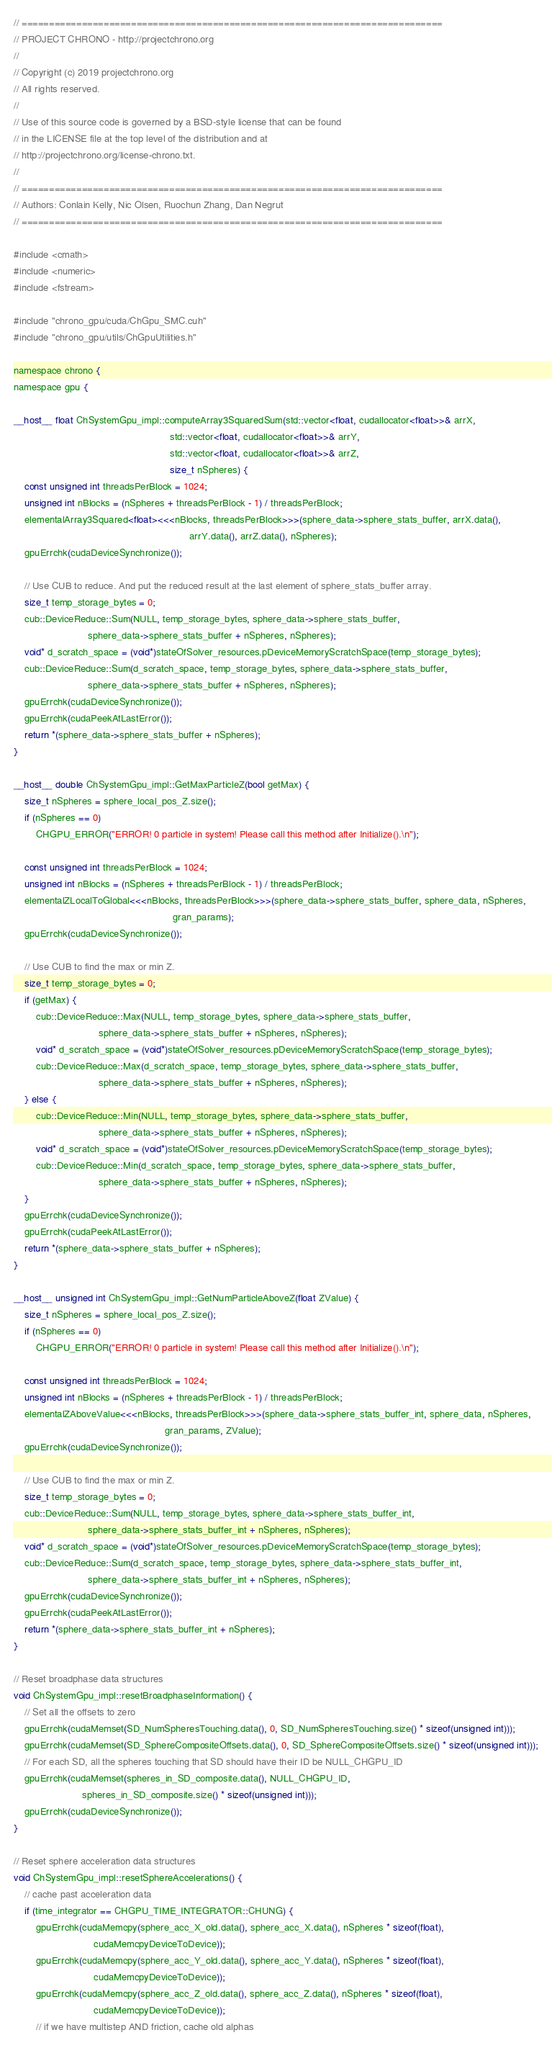Convert code to text. <code><loc_0><loc_0><loc_500><loc_500><_Cuda_>// =============================================================================
// PROJECT CHRONO - http://projectchrono.org
//
// Copyright (c) 2019 projectchrono.org
// All rights reserved.
//
// Use of this source code is governed by a BSD-style license that can be found
// in the LICENSE file at the top level of the distribution and at
// http://projectchrono.org/license-chrono.txt.
//
// =============================================================================
// Authors: Conlain Kelly, Nic Olsen, Ruochun Zhang, Dan Negrut
// =============================================================================

#include <cmath>
#include <numeric>
#include <fstream>

#include "chrono_gpu/cuda/ChGpu_SMC.cuh"
#include "chrono_gpu/utils/ChGpuUtilities.h"

namespace chrono {
namespace gpu {

__host__ float ChSystemGpu_impl::computeArray3SquaredSum(std::vector<float, cudallocator<float>>& arrX,
                                                         std::vector<float, cudallocator<float>>& arrY,
                                                         std::vector<float, cudallocator<float>>& arrZ,
                                                         size_t nSpheres) {
    const unsigned int threadsPerBlock = 1024;
    unsigned int nBlocks = (nSpheres + threadsPerBlock - 1) / threadsPerBlock;
    elementalArray3Squared<float><<<nBlocks, threadsPerBlock>>>(sphere_data->sphere_stats_buffer, arrX.data(),
                                                                arrY.data(), arrZ.data(), nSpheres);
    gpuErrchk(cudaDeviceSynchronize());

    // Use CUB to reduce. And put the reduced result at the last element of sphere_stats_buffer array.
    size_t temp_storage_bytes = 0;
    cub::DeviceReduce::Sum(NULL, temp_storage_bytes, sphere_data->sphere_stats_buffer,
                           sphere_data->sphere_stats_buffer + nSpheres, nSpheres);
    void* d_scratch_space = (void*)stateOfSolver_resources.pDeviceMemoryScratchSpace(temp_storage_bytes);
    cub::DeviceReduce::Sum(d_scratch_space, temp_storage_bytes, sphere_data->sphere_stats_buffer,
                           sphere_data->sphere_stats_buffer + nSpheres, nSpheres);
    gpuErrchk(cudaDeviceSynchronize());
    gpuErrchk(cudaPeekAtLastError());
    return *(sphere_data->sphere_stats_buffer + nSpheres);
}

__host__ double ChSystemGpu_impl::GetMaxParticleZ(bool getMax) {
    size_t nSpheres = sphere_local_pos_Z.size();
    if (nSpheres == 0)
        CHGPU_ERROR("ERROR! 0 particle in system! Please call this method after Initialize().\n");

    const unsigned int threadsPerBlock = 1024;
    unsigned int nBlocks = (nSpheres + threadsPerBlock - 1) / threadsPerBlock;
    elementalZLocalToGlobal<<<nBlocks, threadsPerBlock>>>(sphere_data->sphere_stats_buffer, sphere_data, nSpheres,
                                                          gran_params);
    gpuErrchk(cudaDeviceSynchronize());

    // Use CUB to find the max or min Z.
    size_t temp_storage_bytes = 0;
    if (getMax) {
        cub::DeviceReduce::Max(NULL, temp_storage_bytes, sphere_data->sphere_stats_buffer,
                               sphere_data->sphere_stats_buffer + nSpheres, nSpheres);
        void* d_scratch_space = (void*)stateOfSolver_resources.pDeviceMemoryScratchSpace(temp_storage_bytes);
        cub::DeviceReduce::Max(d_scratch_space, temp_storage_bytes, sphere_data->sphere_stats_buffer,
                               sphere_data->sphere_stats_buffer + nSpheres, nSpheres);
    } else {
        cub::DeviceReduce::Min(NULL, temp_storage_bytes, sphere_data->sphere_stats_buffer,
                               sphere_data->sphere_stats_buffer + nSpheres, nSpheres);
        void* d_scratch_space = (void*)stateOfSolver_resources.pDeviceMemoryScratchSpace(temp_storage_bytes);
        cub::DeviceReduce::Min(d_scratch_space, temp_storage_bytes, sphere_data->sphere_stats_buffer,
                               sphere_data->sphere_stats_buffer + nSpheres, nSpheres);
    }
    gpuErrchk(cudaDeviceSynchronize());
    gpuErrchk(cudaPeekAtLastError());
    return *(sphere_data->sphere_stats_buffer + nSpheres);
}

__host__ unsigned int ChSystemGpu_impl::GetNumParticleAboveZ(float ZValue) {
    size_t nSpheres = sphere_local_pos_Z.size();
    if (nSpheres == 0)
        CHGPU_ERROR("ERROR! 0 particle in system! Please call this method after Initialize().\n");

    const unsigned int threadsPerBlock = 1024;
    unsigned int nBlocks = (nSpheres + threadsPerBlock - 1) / threadsPerBlock;
    elementalZAboveValue<<<nBlocks, threadsPerBlock>>>(sphere_data->sphere_stats_buffer_int, sphere_data, nSpheres,
                                                       gran_params, ZValue);
    gpuErrchk(cudaDeviceSynchronize());

    // Use CUB to find the max or min Z.
    size_t temp_storage_bytes = 0;
    cub::DeviceReduce::Sum(NULL, temp_storage_bytes, sphere_data->sphere_stats_buffer_int,
                           sphere_data->sphere_stats_buffer_int + nSpheres, nSpheres);
    void* d_scratch_space = (void*)stateOfSolver_resources.pDeviceMemoryScratchSpace(temp_storage_bytes);
    cub::DeviceReduce::Sum(d_scratch_space, temp_storage_bytes, sphere_data->sphere_stats_buffer_int,
                           sphere_data->sphere_stats_buffer_int + nSpheres, nSpheres);
    gpuErrchk(cudaDeviceSynchronize());
    gpuErrchk(cudaPeekAtLastError());
    return *(sphere_data->sphere_stats_buffer_int + nSpheres);
}

// Reset broadphase data structures
void ChSystemGpu_impl::resetBroadphaseInformation() {
    // Set all the offsets to zero
    gpuErrchk(cudaMemset(SD_NumSpheresTouching.data(), 0, SD_NumSpheresTouching.size() * sizeof(unsigned int)));
    gpuErrchk(cudaMemset(SD_SphereCompositeOffsets.data(), 0, SD_SphereCompositeOffsets.size() * sizeof(unsigned int)));
    // For each SD, all the spheres touching that SD should have their ID be NULL_CHGPU_ID
    gpuErrchk(cudaMemset(spheres_in_SD_composite.data(), NULL_CHGPU_ID,
                         spheres_in_SD_composite.size() * sizeof(unsigned int)));
    gpuErrchk(cudaDeviceSynchronize());
}

// Reset sphere acceleration data structures
void ChSystemGpu_impl::resetSphereAccelerations() {
    // cache past acceleration data
    if (time_integrator == CHGPU_TIME_INTEGRATOR::CHUNG) {
        gpuErrchk(cudaMemcpy(sphere_acc_X_old.data(), sphere_acc_X.data(), nSpheres * sizeof(float),
                             cudaMemcpyDeviceToDevice));
        gpuErrchk(cudaMemcpy(sphere_acc_Y_old.data(), sphere_acc_Y.data(), nSpheres * sizeof(float),
                             cudaMemcpyDeviceToDevice));
        gpuErrchk(cudaMemcpy(sphere_acc_Z_old.data(), sphere_acc_Z.data(), nSpheres * sizeof(float),
                             cudaMemcpyDeviceToDevice));
        // if we have multistep AND friction, cache old alphas</code> 